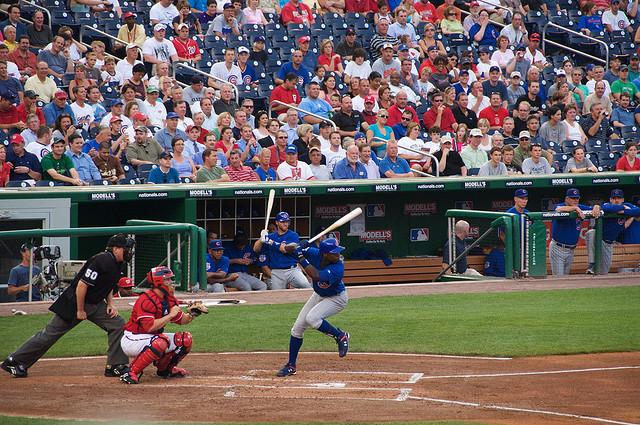What sport is being played?
Write a very short answer. Baseball. Is the stadium packed?
Be succinct. No. What is the color the crowd is wearing to support their team?
Give a very brief answer. Blue. Are the stands full?
Keep it brief. Yes. What team is batting?
Keep it brief. Blue team. Is the place crowded?
Answer briefly. Yes. 